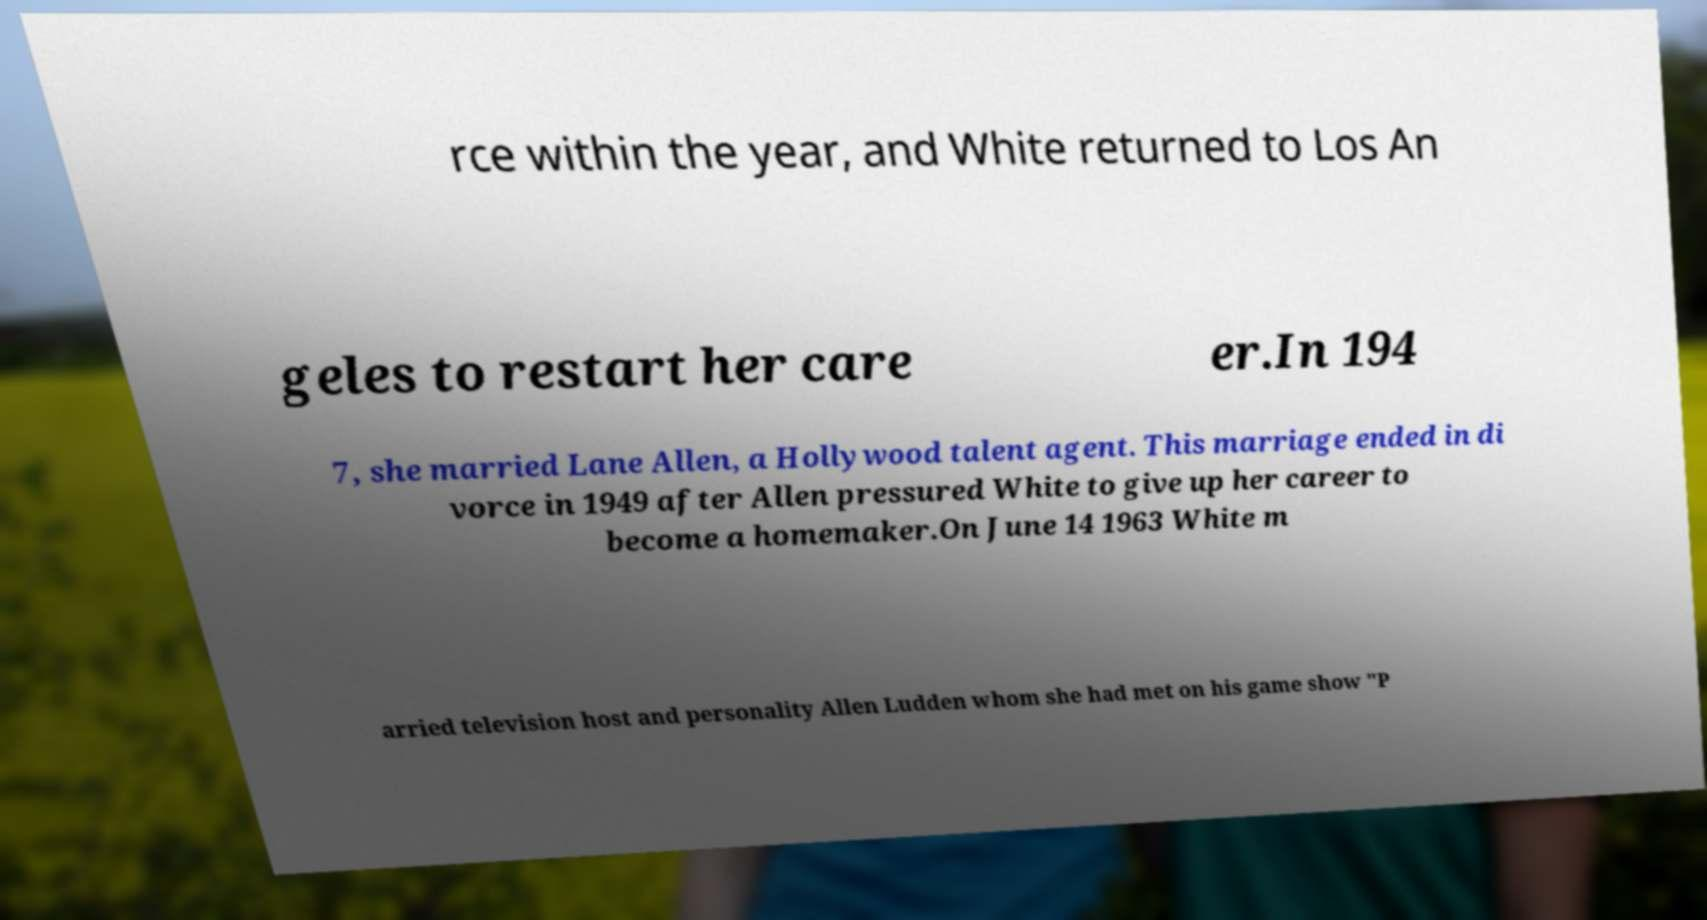I need the written content from this picture converted into text. Can you do that? rce within the year, and White returned to Los An geles to restart her care er.In 194 7, she married Lane Allen, a Hollywood talent agent. This marriage ended in di vorce in 1949 after Allen pressured White to give up her career to become a homemaker.On June 14 1963 White m arried television host and personality Allen Ludden whom she had met on his game show "P 